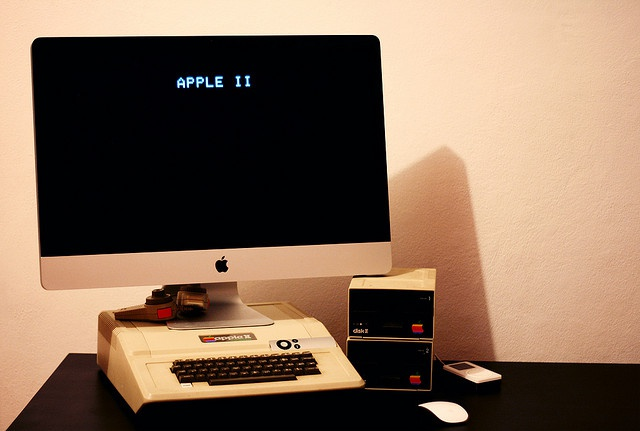Describe the objects in this image and their specific colors. I can see tv in tan and black tones, keyboard in tan, black, maroon, and brown tones, remote in tan, black, and maroon tones, remote in tan, black, maroon, and brown tones, and cell phone in tan and black tones in this image. 